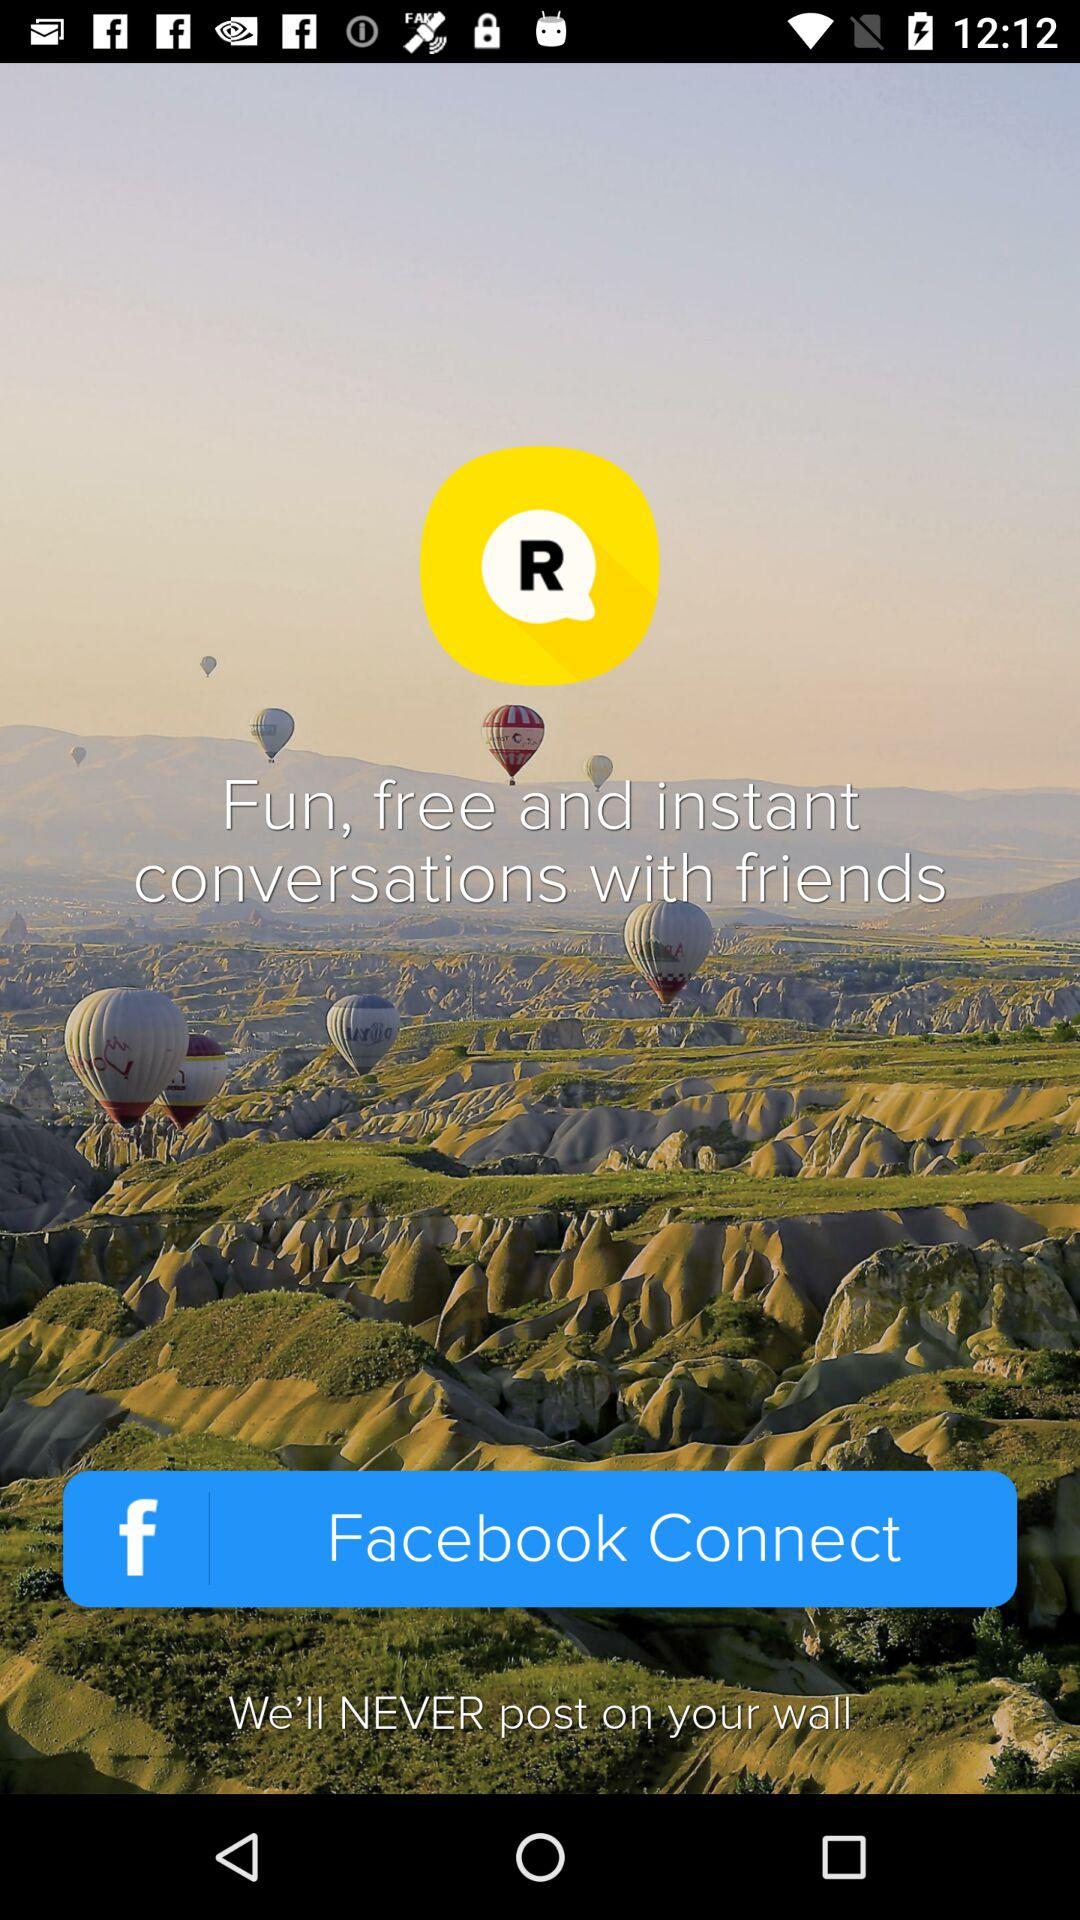Through which given application can we connect? You can connect through "Facebook". 